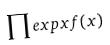Convert formula to latex. <formula><loc_0><loc_0><loc_500><loc_500>\prod e x p x f ( x )</formula> 